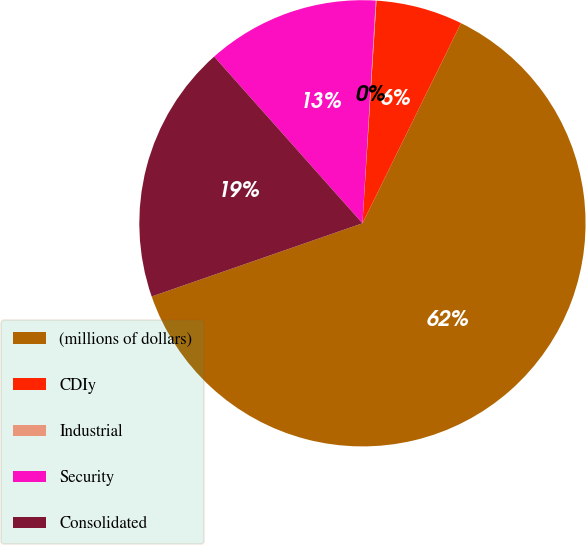<chart> <loc_0><loc_0><loc_500><loc_500><pie_chart><fcel>(millions of dollars)<fcel>CDIy<fcel>Industrial<fcel>Security<fcel>Consolidated<nl><fcel>62.39%<fcel>6.28%<fcel>0.05%<fcel>12.52%<fcel>18.75%<nl></chart> 